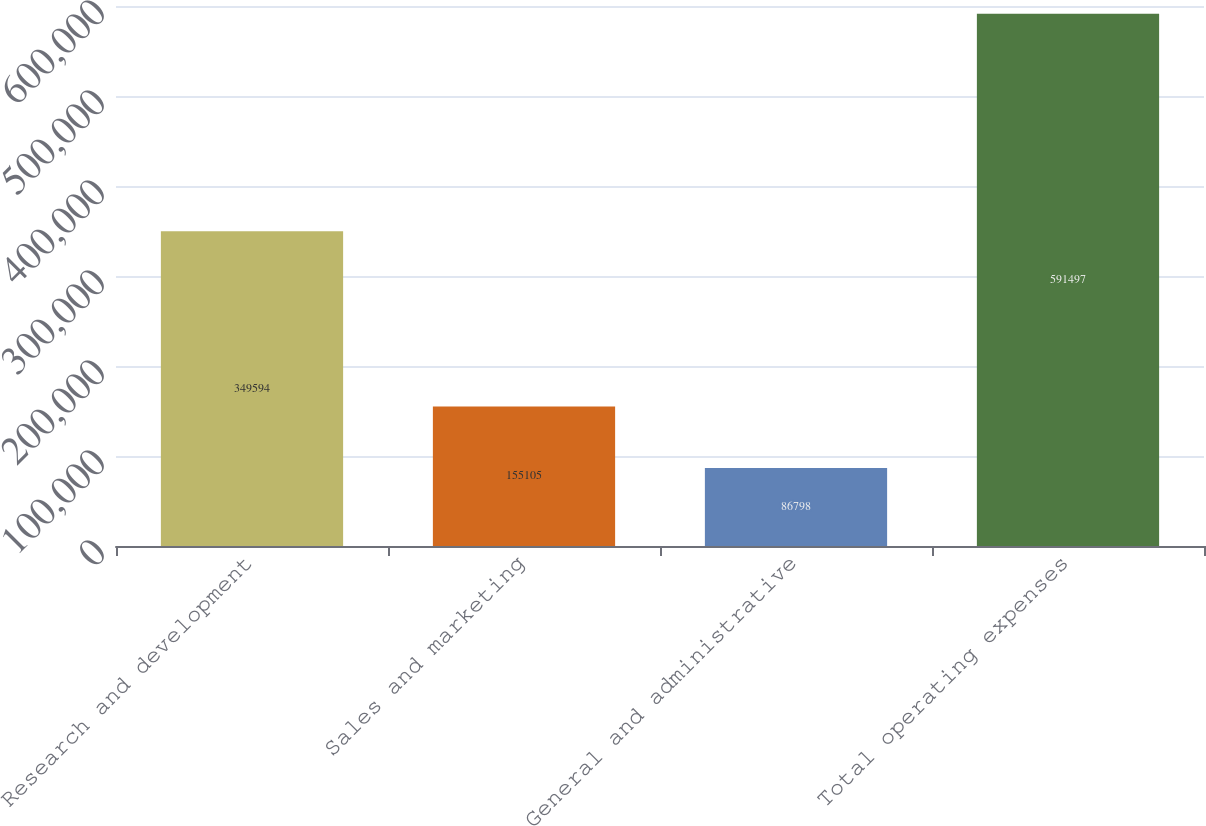Convert chart. <chart><loc_0><loc_0><loc_500><loc_500><bar_chart><fcel>Research and development<fcel>Sales and marketing<fcel>General and administrative<fcel>Total operating expenses<nl><fcel>349594<fcel>155105<fcel>86798<fcel>591497<nl></chart> 